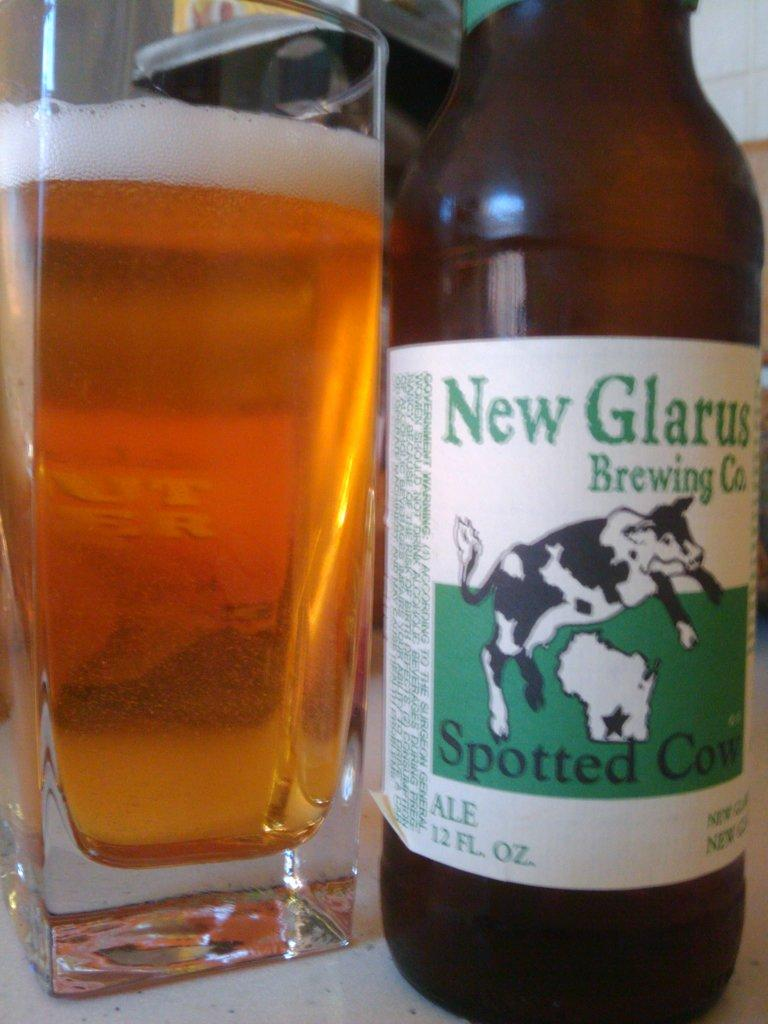<image>
Offer a succinct explanation of the picture presented. A bottle of New Glarus ale sits next to a full glass. 